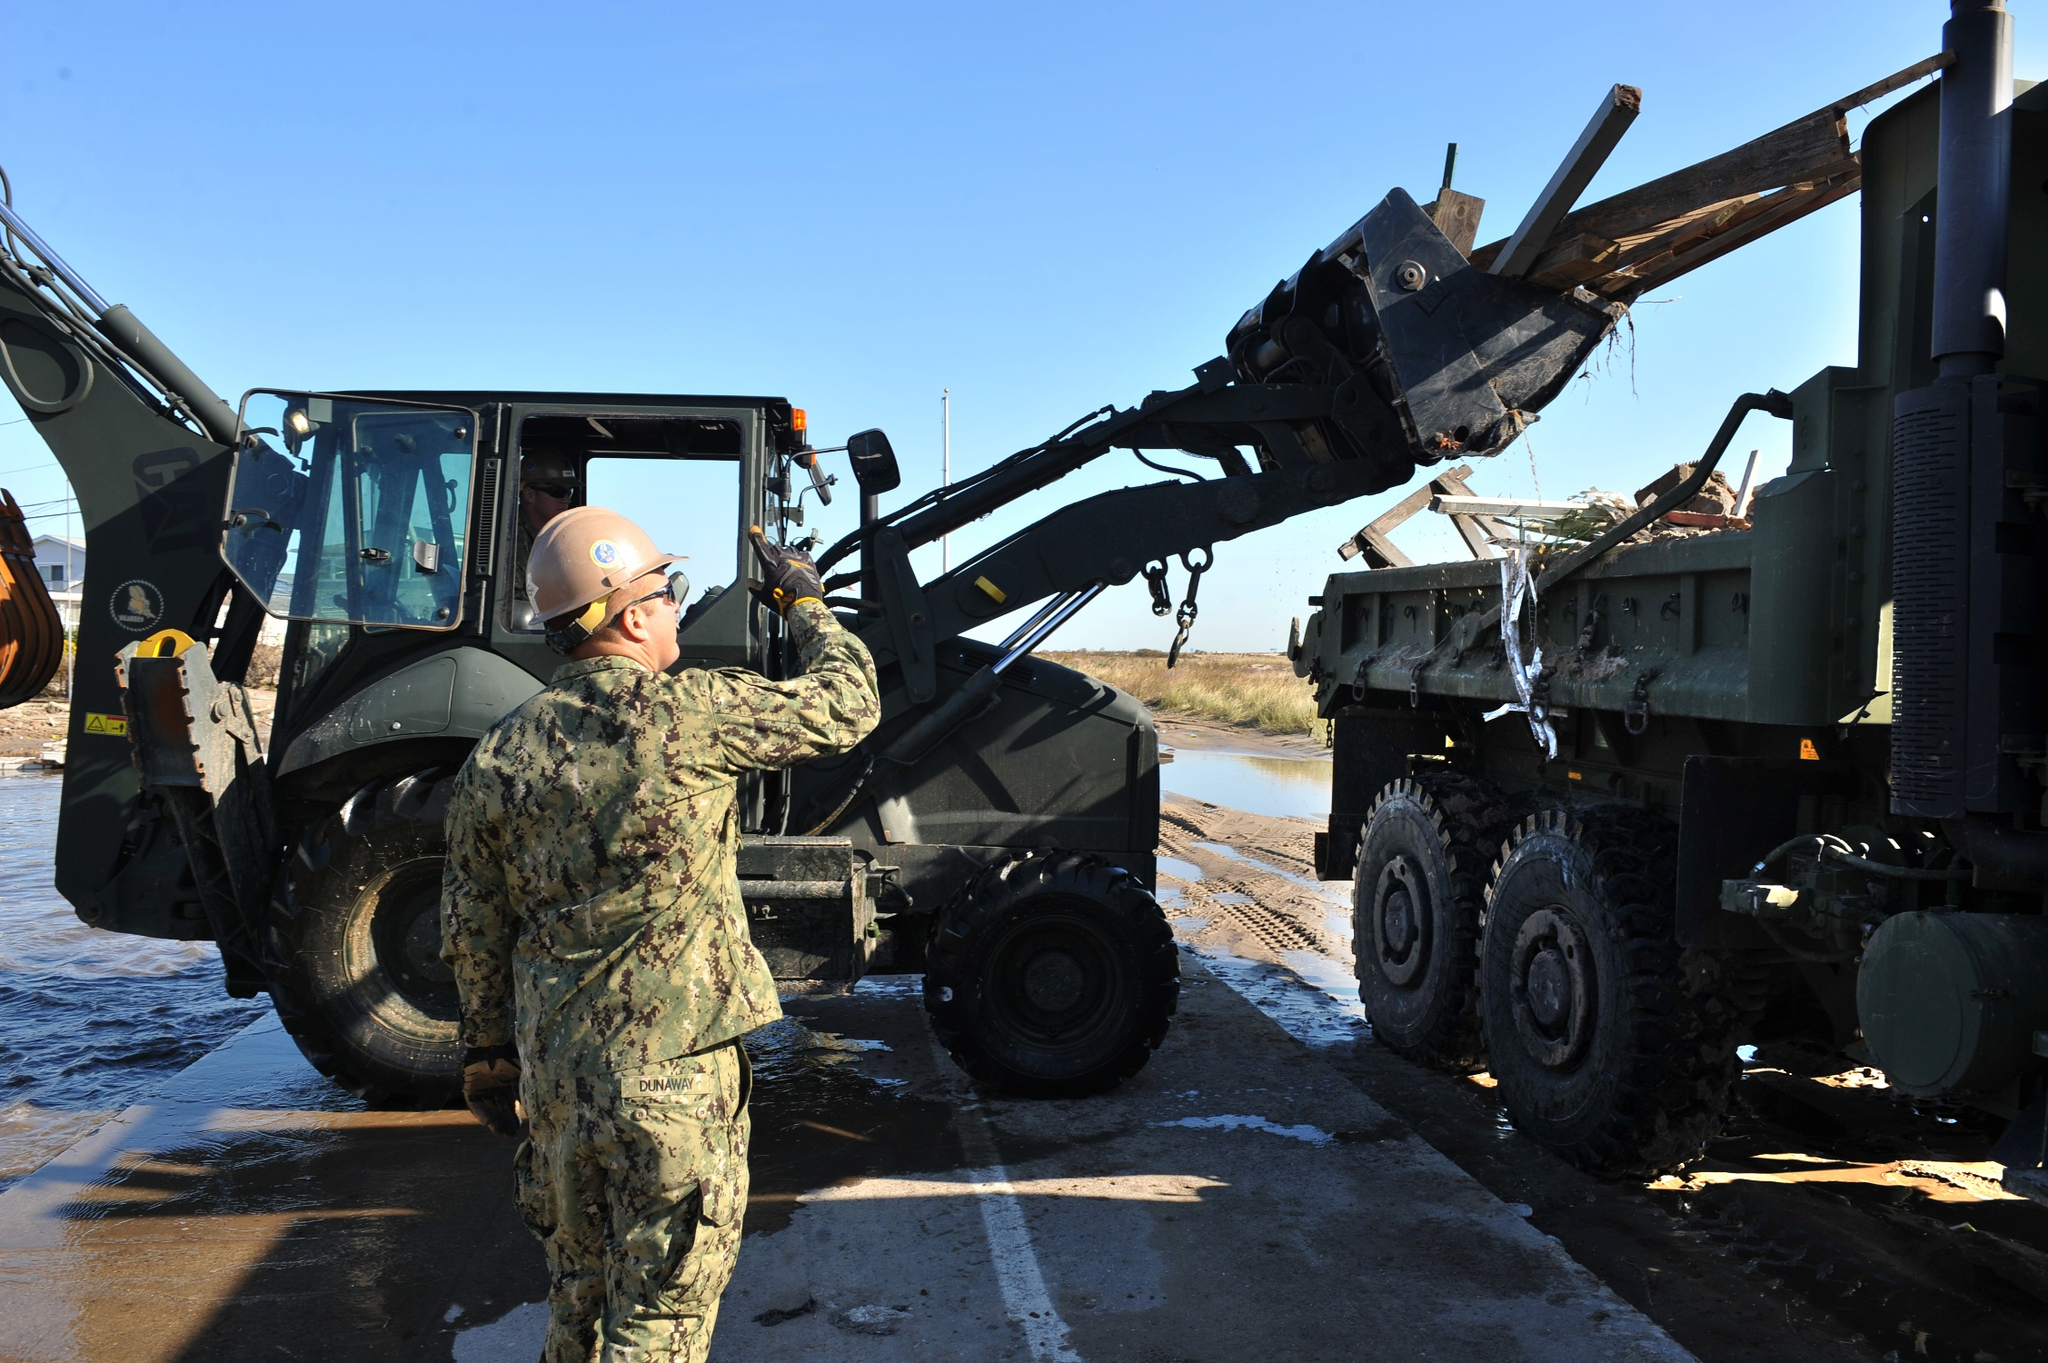Can you describe the main action occurring in this construction site? In this construction site, a worker is meticulously operating a forklift to move a large wooden beam from a military truck. The scene is set under a clear blue sky, with the truck and forklift positioned on a dirt pathway next to a serene body of water. The worker, dressed in military camouflage and a hard hat, exemplifies focus and precision as the beam is carefully lifted from the truck's cargo area. 